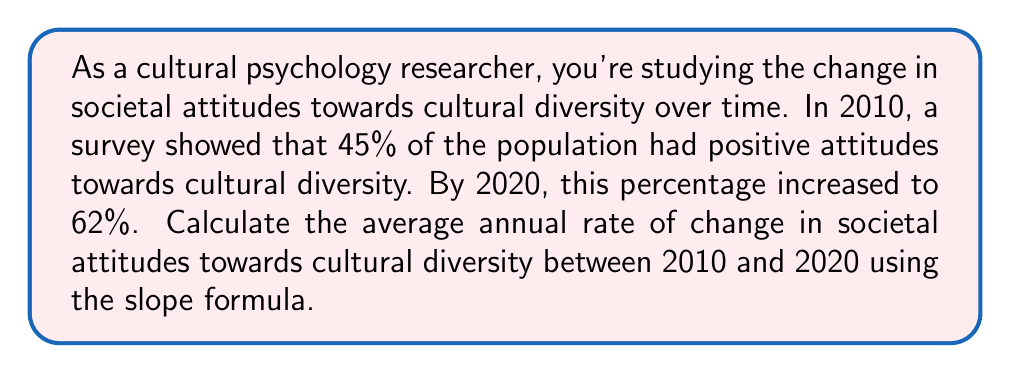Teach me how to tackle this problem. To solve this problem, we'll use the slope formula, which is:

$$ m = \frac{y_2 - y_1}{x_2 - x_1} $$

Where:
$m$ = slope (rate of change)
$(x_1, y_1)$ = initial point
$(x_2, y_2)$ = final point

Step 1: Identify the points
- Initial point (2010, 45%): $(x_1, y_1) = (2010, 45)$
- Final point (2020, 62%): $(x_2, y_2) = (2020, 62)$

Step 2: Apply the slope formula
$$ m = \frac{62 - 45}{2020 - 2010} = \frac{17}{10} = 1.7 $$

Step 3: Interpret the result
The slope of 1.7 represents the average annual increase in the percentage of the population with positive attitudes towards cultural diversity.

Therefore, the average annual rate of change in societal attitudes towards cultural diversity between 2010 and 2020 is 1.7% per year.
Answer: 1.7% per year 